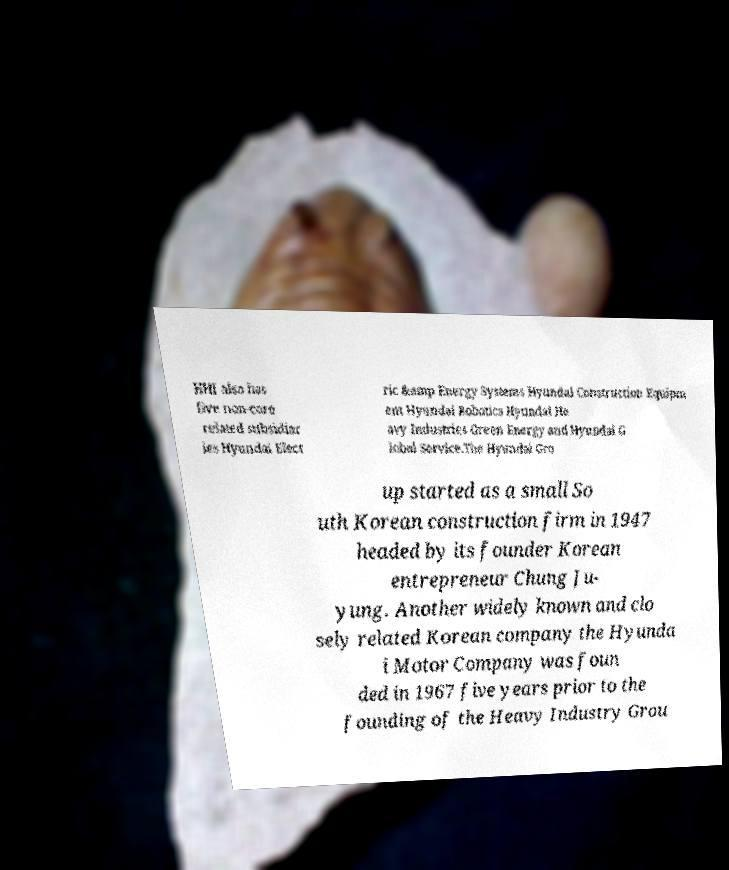For documentation purposes, I need the text within this image transcribed. Could you provide that? HHI also has five non-core related subsidiar ies Hyundai Elect ric &amp Energy Systems Hyundai Construction Equipm ent Hyundai Robotics Hyundai He avy Industries Green Energy and Hyundai G lobal Service.The Hyundai Gro up started as a small So uth Korean construction firm in 1947 headed by its founder Korean entrepreneur Chung Ju- yung. Another widely known and clo sely related Korean company the Hyunda i Motor Company was foun ded in 1967 five years prior to the founding of the Heavy Industry Grou 